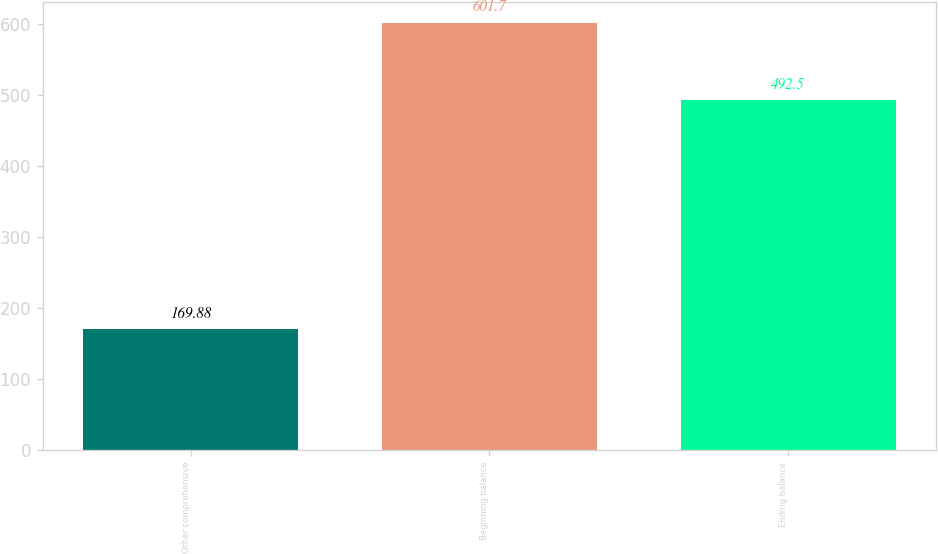Convert chart. <chart><loc_0><loc_0><loc_500><loc_500><bar_chart><fcel>Other comprehensive<fcel>Beginning balance<fcel>Ending balance<nl><fcel>169.88<fcel>601.7<fcel>492.5<nl></chart> 